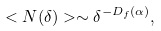Convert formula to latex. <formula><loc_0><loc_0><loc_500><loc_500>< N ( \delta ) > \sim \delta ^ { - D _ { f } ( \alpha ) } ,</formula> 